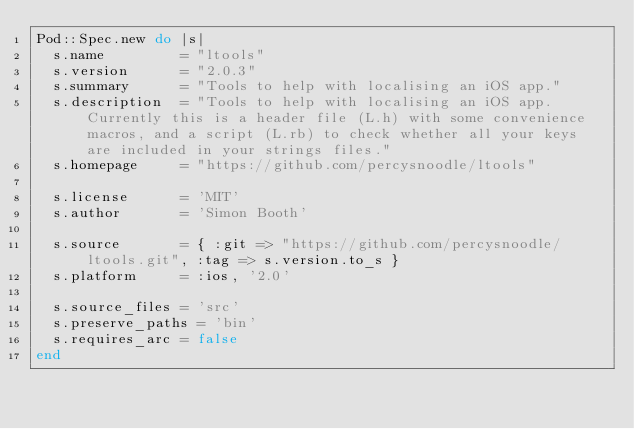Convert code to text. <code><loc_0><loc_0><loc_500><loc_500><_Ruby_>Pod::Spec.new do |s|
  s.name         = "ltools"
  s.version      = "2.0.3"
  s.summary      = "Tools to help with localising an iOS app."
  s.description  = "Tools to help with localising an iOS app.  Currently this is a header file (L.h) with some convenience macros, and a script (L.rb) to check whether all your keys are included in your strings files."
  s.homepage     = "https://github.com/percysnoodle/ltools"

  s.license      = 'MIT'
  s.author       = 'Simon Booth'

  s.source       = { :git => "https://github.com/percysnoodle/ltools.git", :tag => s.version.to_s }
  s.platform     = :ios, '2.0'

  s.source_files = 'src'
  s.preserve_paths = 'bin'
  s.requires_arc = false
end
</code> 